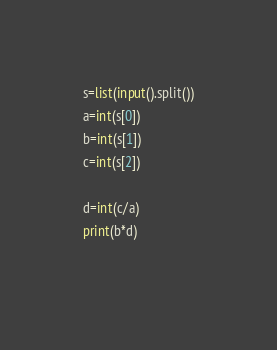<code> <loc_0><loc_0><loc_500><loc_500><_Python_>s=list(input().split())
a=int(s[0])
b=int(s[1])
c=int(s[2])

d=int(c/a)
print(b*d)
  </code> 